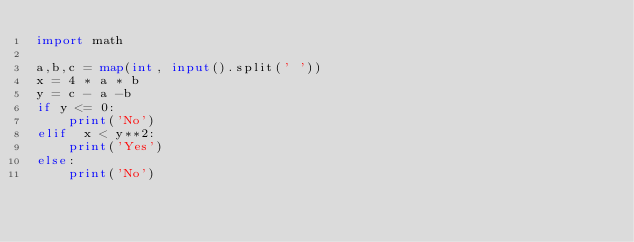Convert code to text. <code><loc_0><loc_0><loc_500><loc_500><_Python_>import math

a,b,c = map(int, input().split(' '))
x = 4 * a * b
y = c - a -b
if y <= 0:
    print('No')
elif  x < y**2:
    print('Yes')
else:
    print('No')</code> 